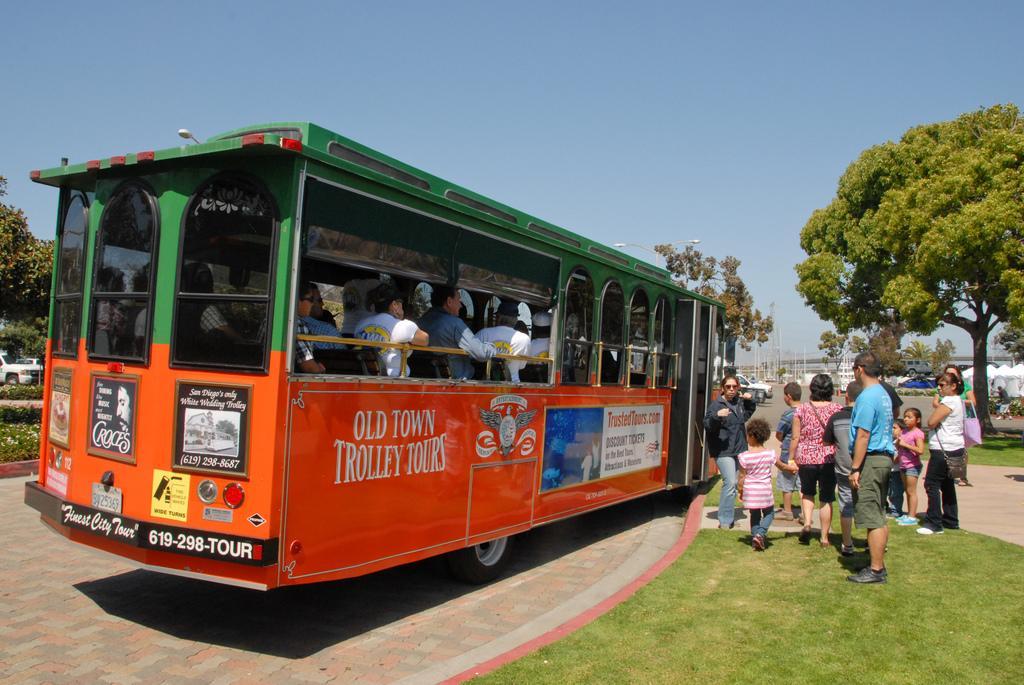Can you describe this image briefly? This is an outside view. Hear I can see a bus on the road. Inside the bus few people are sitting. On the right side there are few people standing on the ground. Here I can see the green color grass. In the background there are some trees and vehicles on the road and also I can see some poles. On the top of the image I can see the sky. 